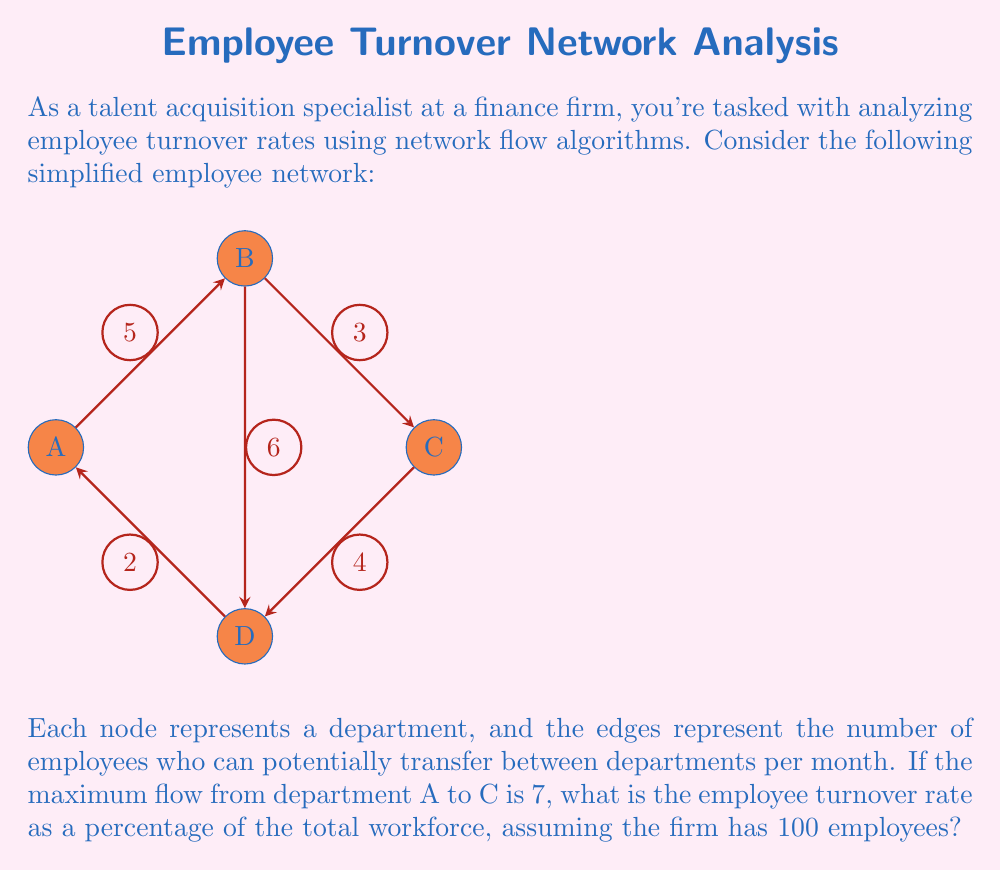Can you answer this question? To solve this problem, we'll follow these steps:

1) First, we need to understand what the maximum flow represents. In this context, the maximum flow from A to C (7 employees) represents the maximum number of employees that can potentially leave the company in a month, moving through the network from A to C.

2) The turnover rate is typically calculated as:

   $$ \text{Turnover Rate} = \frac{\text{Number of Separations}}{\text{Average Number of Employees}} \times 100\% $$

3) In this case:
   - Number of Separations = Maximum Flow = 7
   - Average Number of Employees = 100 (given in the question)

4) Plugging these values into the formula:

   $$ \text{Turnover Rate} = \frac{7}{100} \times 100\% = 7\% $$

Therefore, the employee turnover rate is 7% of the total workforce per month.
Answer: 7% 